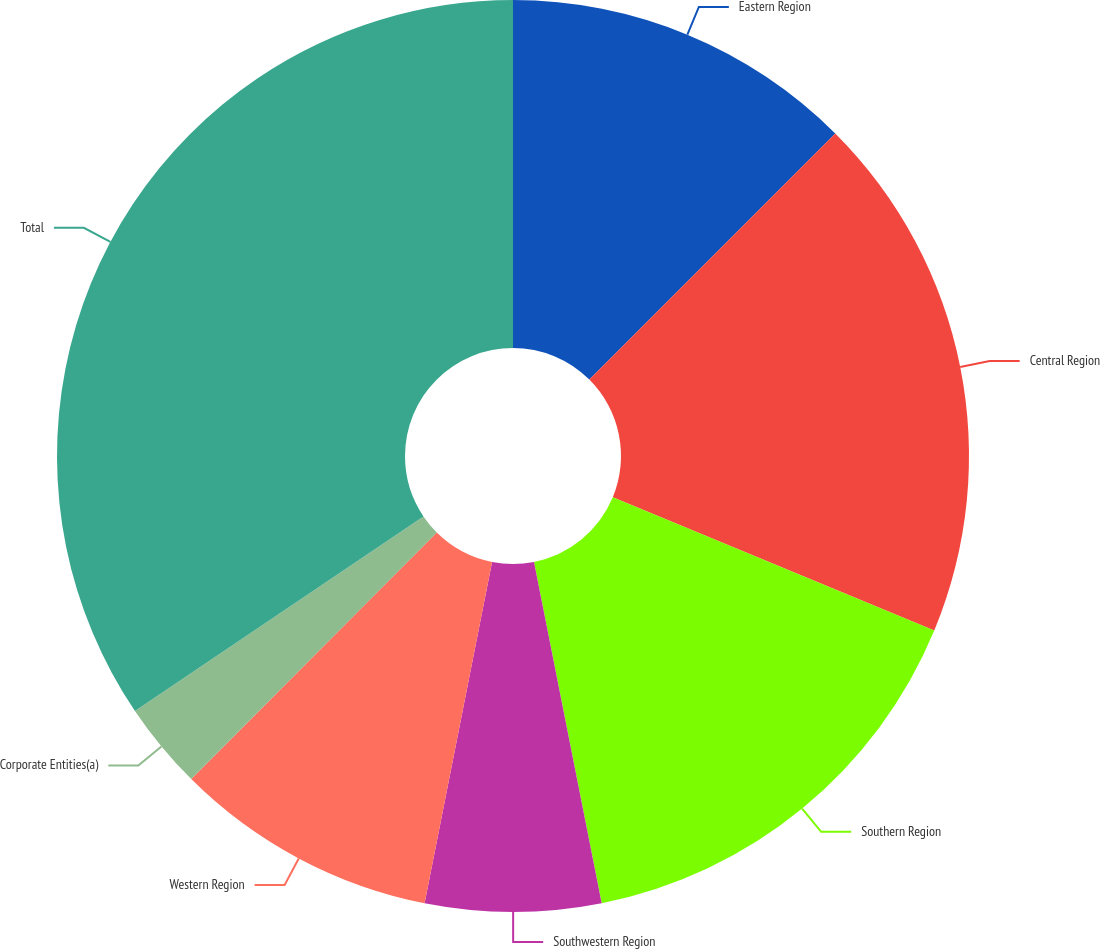Convert chart. <chart><loc_0><loc_0><loc_500><loc_500><pie_chart><fcel>Eastern Region<fcel>Central Region<fcel>Southern Region<fcel>Southwestern Region<fcel>Western Region<fcel>Corporate Entities(a)<fcel>Total<nl><fcel>12.49%<fcel>18.76%<fcel>15.63%<fcel>6.22%<fcel>9.36%<fcel>3.09%<fcel>34.44%<nl></chart> 